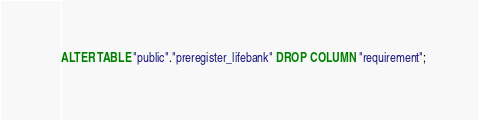<code> <loc_0><loc_0><loc_500><loc_500><_SQL_>ALTER TABLE "public"."preregister_lifebank" DROP COLUMN "requirement";
</code> 